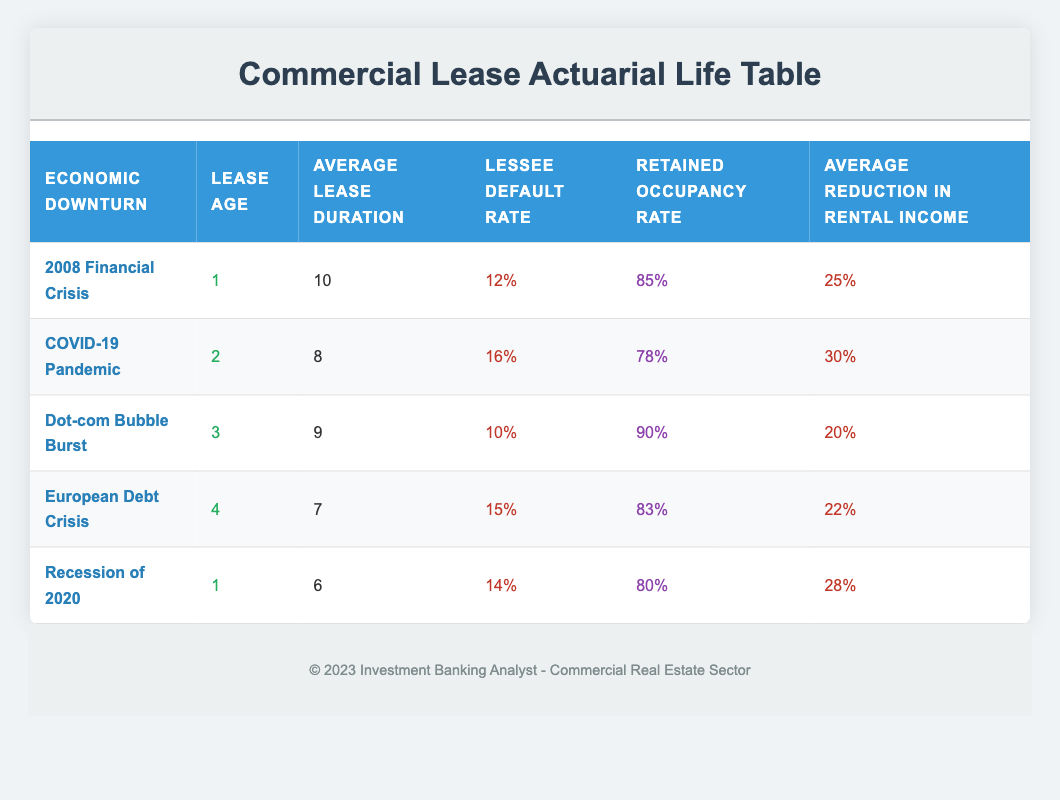What was the lessee default rate during the COVID-19 pandemic? From the table, the lessee default rate during the COVID-19 pandemic is listed as 16%.
Answer: 16% Which economic downturn had the highest average reduction in rental income? Comparing the average reduction in rental income across all economic downturns, the COVID-19 pandemic has the highest at 30%.
Answer: 30% What is the average lease duration for the leases affected by the European Debt Crisis? According to the table, the average lease duration during the European Debt Crisis is 7 years.
Answer: 7 Is the retained occupancy rate lower for the 2008 financial crisis compared to the recession of 2020? The retained occupancy rate for the 2008 financial crisis is 85%, while for the recession of 2020 it is 80%, which confirms that the rate is indeed lower for the latter.
Answer: Yes What was the average lease duration of leases affected by economic downturns with a lessee default rate higher than 15%? The downturns with a lessee default rate higher than 15% are the COVID-19 pandemic (8 years), European Debt Crisis (7 years), and the Recession of 2020 (6 years). The average is (8 + 7 + 6) / 3 = 21 / 3 = 7 years.
Answer: 7 If we combine the average lease durations of the 2008 Financial Crisis and the Dot-com Bubble Burst, what is the total? The average lease duration for the 2008 Financial Crisis is 10 years and for the Dot-com Bubble Burst is 9 years. Adding them gives 10 + 9 = 19 years total.
Answer: 19 Which downturn has the lowest lessee default rate? Upon reviewing the table, the Dot-com Bubble Burst has the lowest lessee default rate of 10%.
Answer: 10% What is the retained occupancy rate for the downturn with the longest average lease duration? The longest average lease duration is 10 years during the 2008 Financial Crisis, which has a retained occupancy rate of 85%.
Answer: 85 